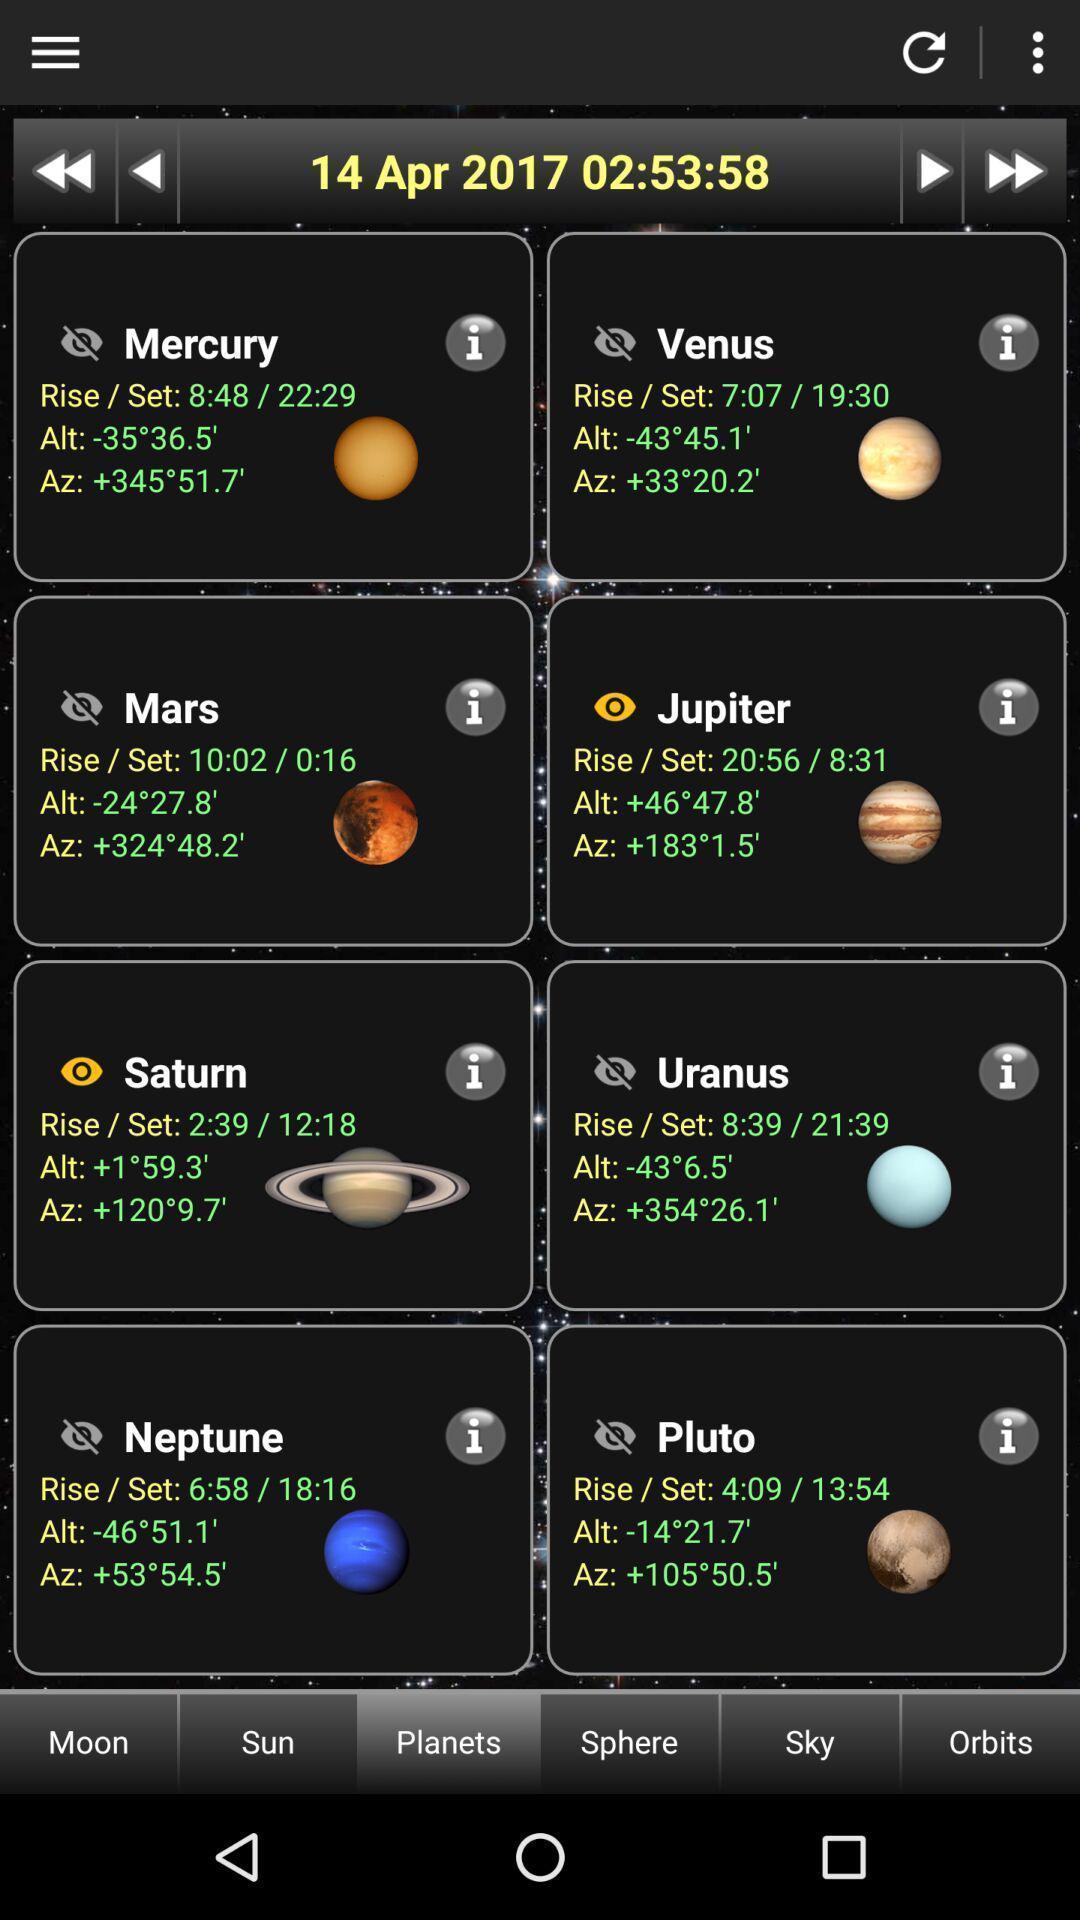Summarize the main components in this picture. Screen showing planets. 